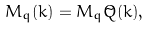Convert formula to latex. <formula><loc_0><loc_0><loc_500><loc_500>M _ { q } ( k ) = M _ { q } \tilde { Q } ( k ) ,</formula> 